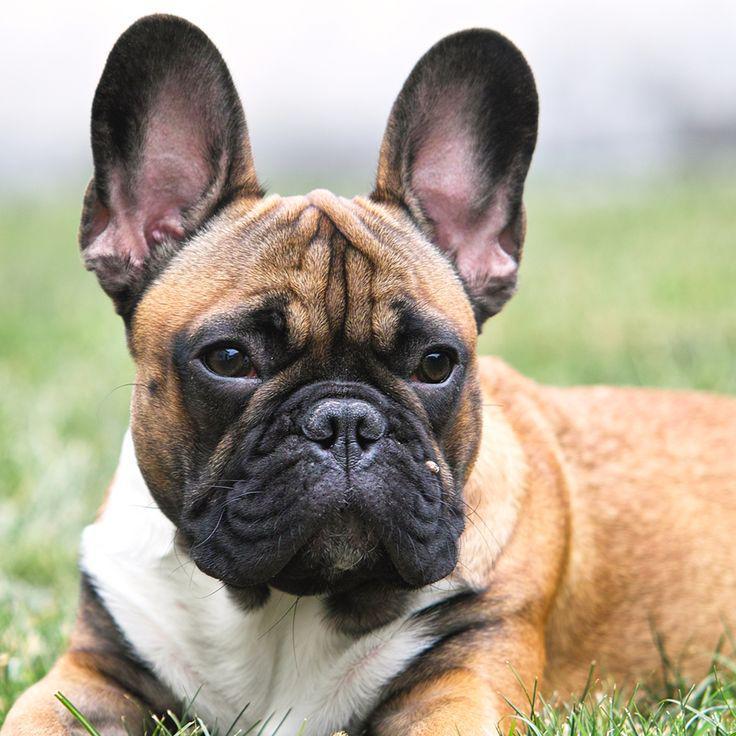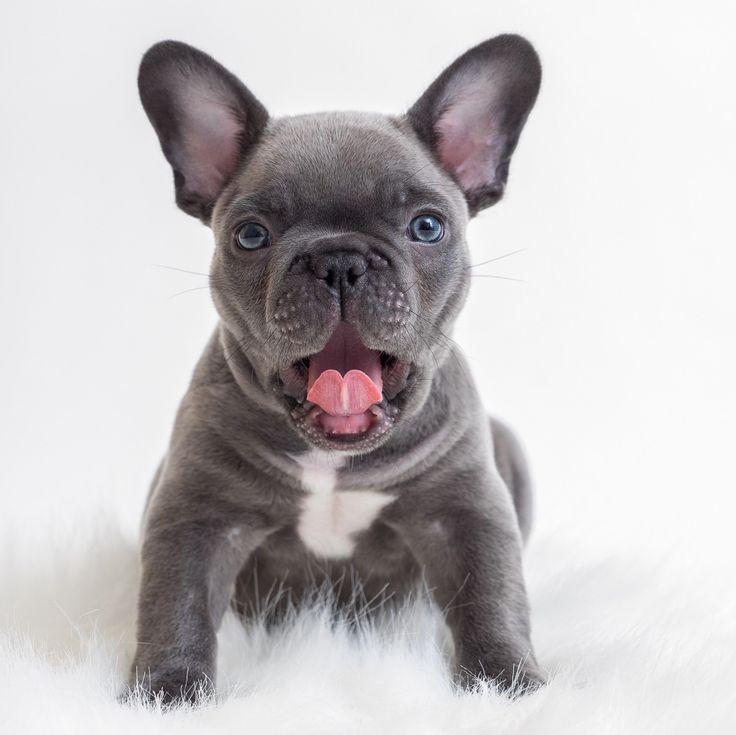The first image is the image on the left, the second image is the image on the right. For the images shown, is this caption "Each image contains a single dog, which is gazing toward the front and has its mouth closed." true? Answer yes or no. No. The first image is the image on the left, the second image is the image on the right. For the images displayed, is the sentence "One of the images features a dog that is wearing a collar." factually correct? Answer yes or no. No. 